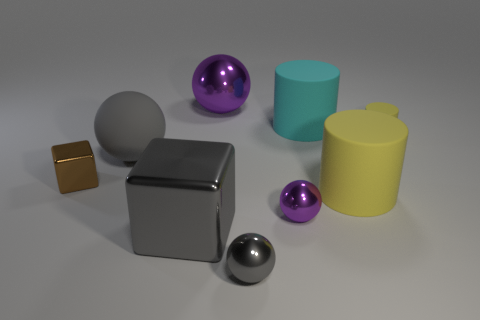How many yellow cylinders must be subtracted to get 1 yellow cylinders? 1 Subtract 1 balls. How many balls are left? 3 Add 1 small gray metallic spheres. How many objects exist? 10 Subtract all cylinders. How many objects are left? 6 Subtract 0 purple cubes. How many objects are left? 9 Subtract all purple metallic things. Subtract all small yellow cylinders. How many objects are left? 6 Add 1 cyan rubber cylinders. How many cyan rubber cylinders are left? 2 Add 8 large cyan matte things. How many large cyan matte things exist? 9 